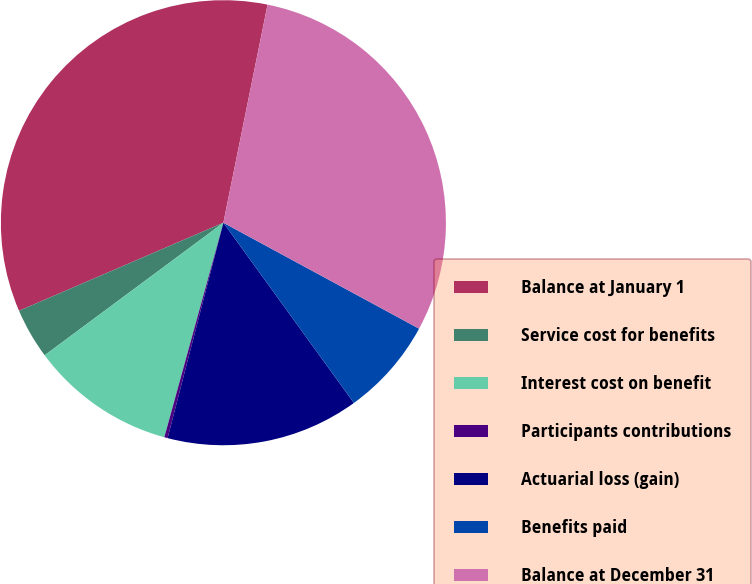Convert chart to OTSL. <chart><loc_0><loc_0><loc_500><loc_500><pie_chart><fcel>Balance at January 1<fcel>Service cost for benefits<fcel>Interest cost on benefit<fcel>Participants contributions<fcel>Actuarial loss (gain)<fcel>Benefits paid<fcel>Balance at December 31<nl><fcel>34.66%<fcel>3.68%<fcel>10.57%<fcel>0.24%<fcel>14.01%<fcel>7.13%<fcel>29.72%<nl></chart> 